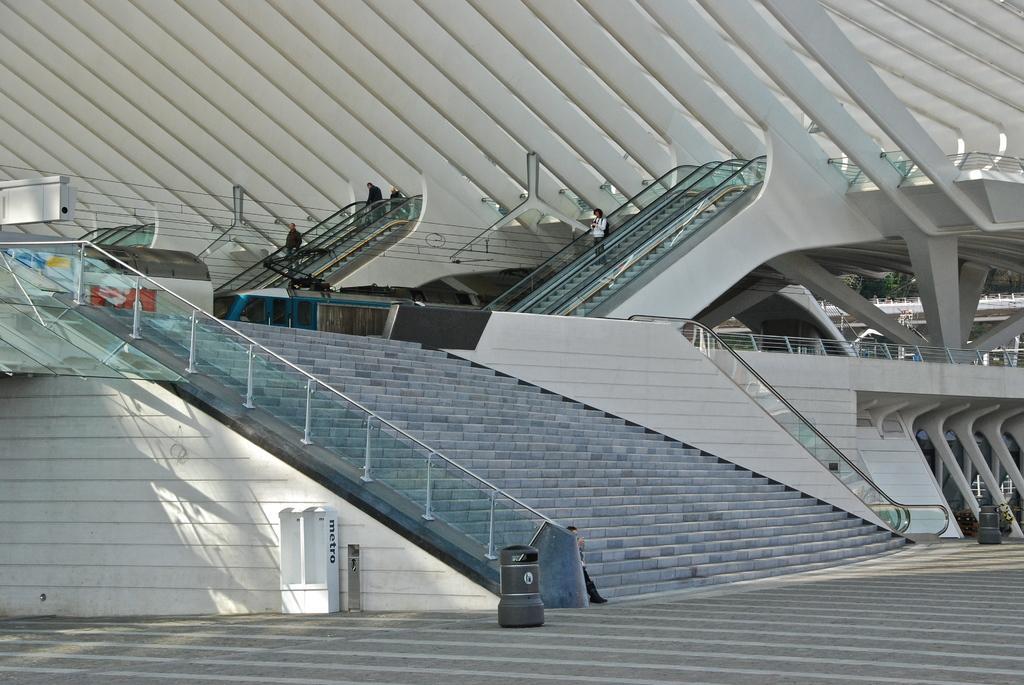How would you summarize this image in a sentence or two? As we can see in the image there is a building, fence and stairs. Here there are few people. 